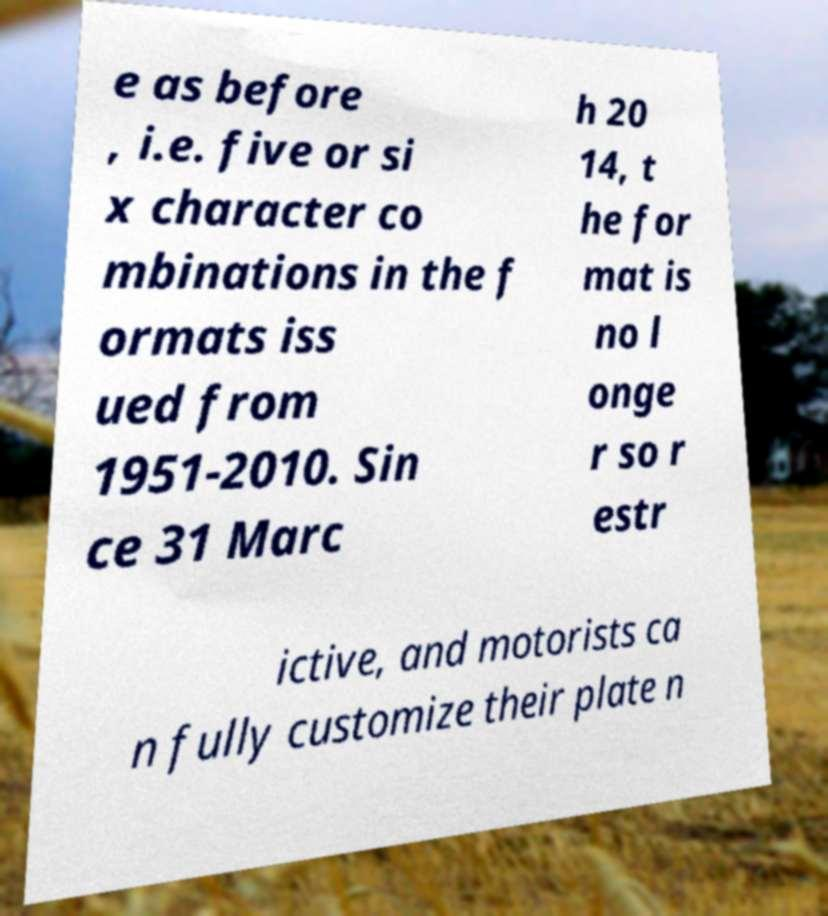Could you extract and type out the text from this image? e as before , i.e. five or si x character co mbinations in the f ormats iss ued from 1951-2010. Sin ce 31 Marc h 20 14, t he for mat is no l onge r so r estr ictive, and motorists ca n fully customize their plate n 